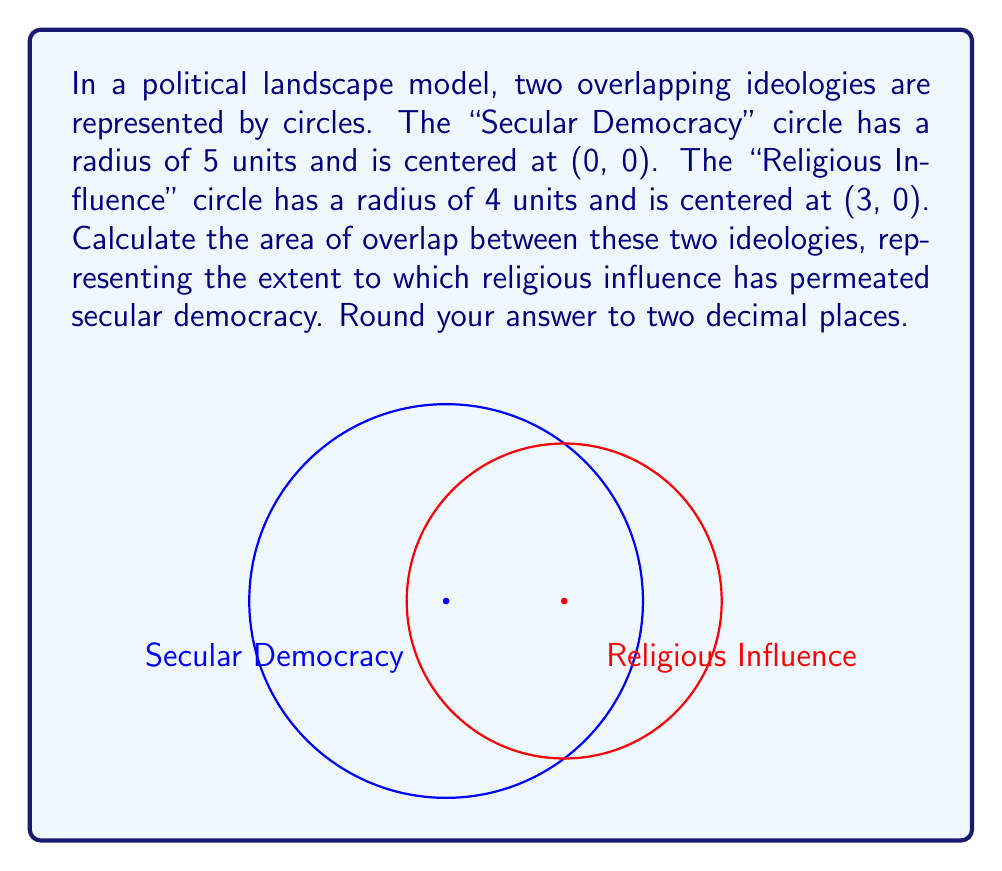Solve this math problem. To solve this problem, we'll use the formula for the area of intersection between two circles. Let's approach this step-by-step:

1) First, we need to calculate the distance $d$ between the centers of the circles:
   $$d = \sqrt{(3-0)^2 + (0-0)^2} = 3$$

2) Now, we'll use the formula for the area of intersection:
   $$A = r_1^2 \arccos(\frac{d^2 + r_1^2 - r_2^2}{2dr_1}) + r_2^2 \arccos(\frac{d^2 + r_2^2 - r_1^2}{2dr_2}) - \frac{1}{2}\sqrt{(-d+r_1+r_2)(d+r_1-r_2)(d-r_1+r_2)(d+r_1+r_2)}$$

   Where $r_1 = 5$ (radius of Secular Democracy circle) and $r_2 = 4$ (radius of Religious Influence circle)

3) Let's calculate each part:
   $$\arccos(\frac{3^2 + 5^2 - 4^2}{2 \cdot 3 \cdot 5}) = \arccos(0.9167) = 0.4115$$
   $$\arccos(\frac{3^2 + 4^2 - 5^2}{2 \cdot 3 \cdot 4}) = \arccos(0.2917) = 1.2757$$

4) Substituting into the formula:
   $$A = 5^2 \cdot 0.4115 + 4^2 \cdot 1.2757 - \frac{1}{2}\sqrt{(-3+5+4)(3+5-4)(3-5+4)(3+5+4)}$$
   $$A = 10.2875 + 20.4112 - \frac{1}{2}\sqrt{6 \cdot 4 \cdot 2 \cdot 12}$$
   $$A = 30.6987 - \frac{1}{2}\sqrt{576} = 30.6987 - 12 = 18.6987$$

5) Rounding to two decimal places:
   $$A \approx 18.70$$
Answer: 18.70 square units 